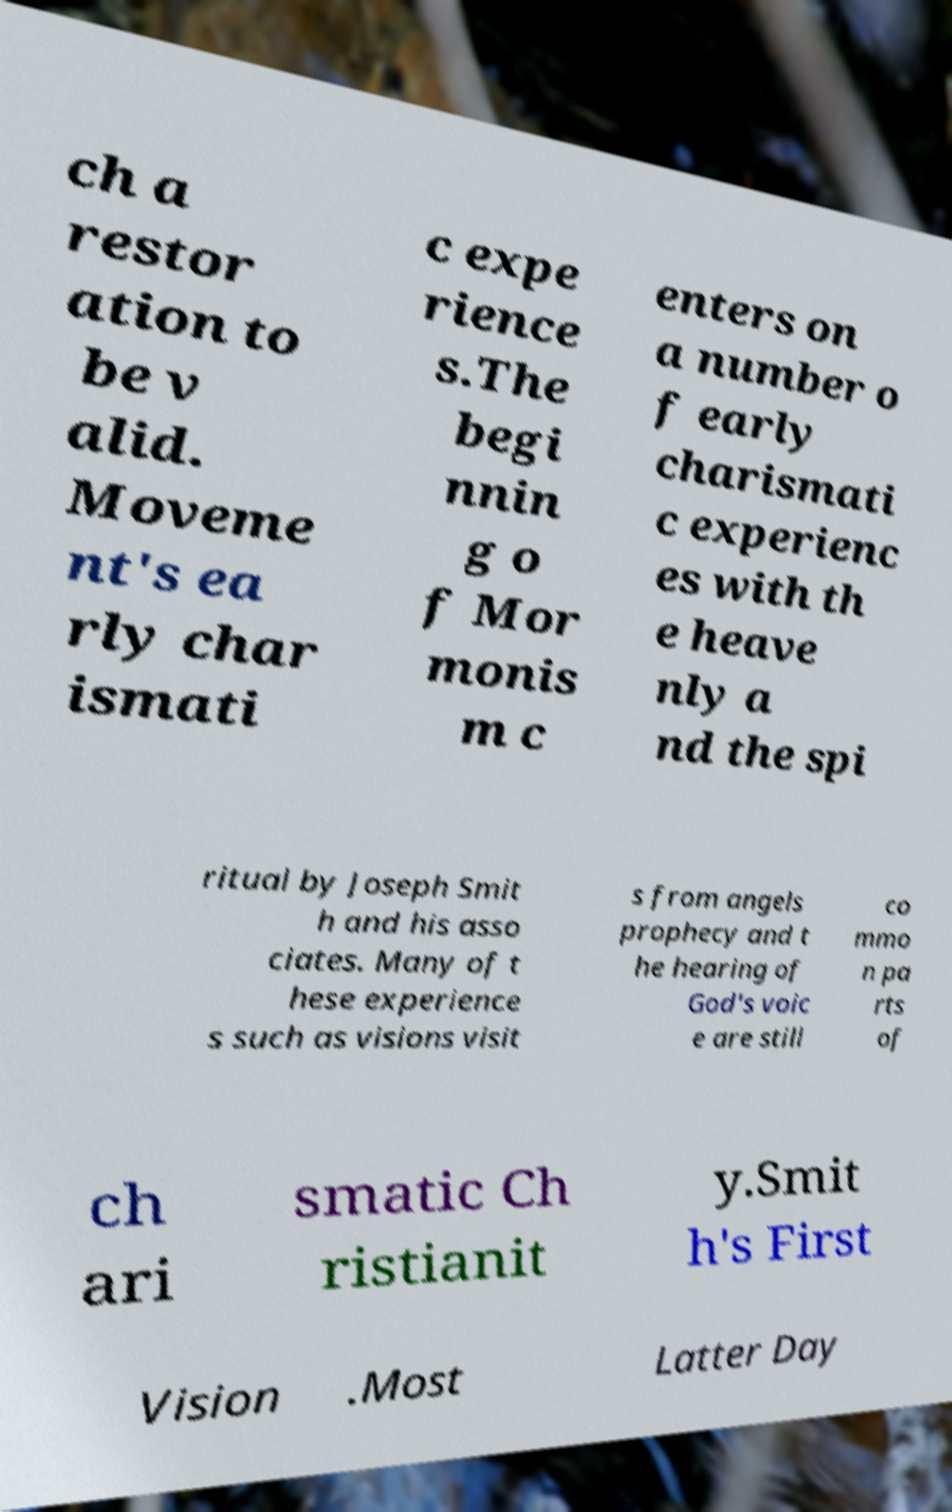Can you read and provide the text displayed in the image?This photo seems to have some interesting text. Can you extract and type it out for me? ch a restor ation to be v alid. Moveme nt's ea rly char ismati c expe rience s.The begi nnin g o f Mor monis m c enters on a number o f early charismati c experienc es with th e heave nly a nd the spi ritual by Joseph Smit h and his asso ciates. Many of t hese experience s such as visions visit s from angels prophecy and t he hearing of God's voic e are still co mmo n pa rts of ch ari smatic Ch ristianit y.Smit h's First Vision .Most Latter Day 